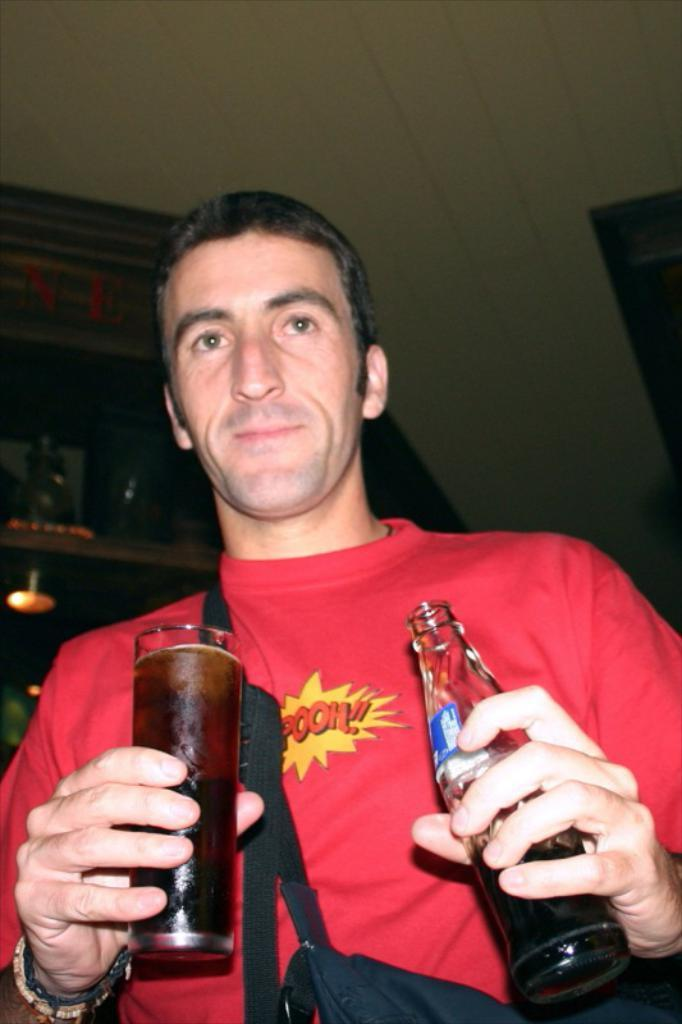Who is present in the image? There is a person in the image. What is the person holding in the image? The person is holding a glass. What is inside the glass? The glass contains a liquid. Can you describe the bottle in the image? There is a bottle with a liquid in the image. Where is the shelf located in the image? There is a shelf in the image, and it is near the person. What is on the shelf? There is a light on the shelf. How does the person's aunt trade with them in the image? There is no mention of an aunt or any trading activity in the image. 